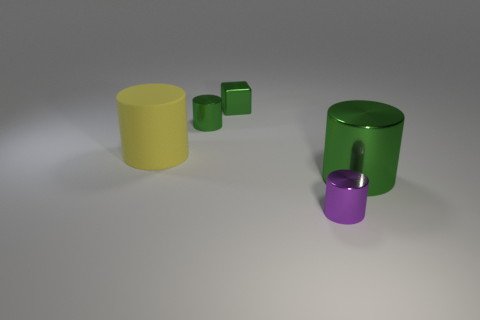Is there anything else that is the same material as the small cube?
Offer a very short reply. Yes. How many things are either metal cylinders behind the big green shiny thing or tiny green objects on the left side of the tiny cube?
Keep it short and to the point. 1. Does the green cube have the same material as the small cylinder behind the yellow rubber cylinder?
Offer a terse response. Yes. What shape is the object that is left of the green metal cube and behind the big yellow matte cylinder?
Provide a short and direct response. Cylinder. What number of other objects are there of the same color as the large matte thing?
Provide a succinct answer. 0. The yellow thing has what shape?
Your answer should be compact. Cylinder. What is the color of the tiny cylinder behind the green metallic cylinder that is to the right of the tiny purple metallic cylinder?
Provide a short and direct response. Green. Does the block have the same color as the tiny object left of the small block?
Offer a terse response. Yes. There is a thing that is in front of the rubber cylinder and behind the purple object; what material is it?
Give a very brief answer. Metal. Is there a green metal cylinder that has the same size as the yellow cylinder?
Offer a very short reply. Yes. 